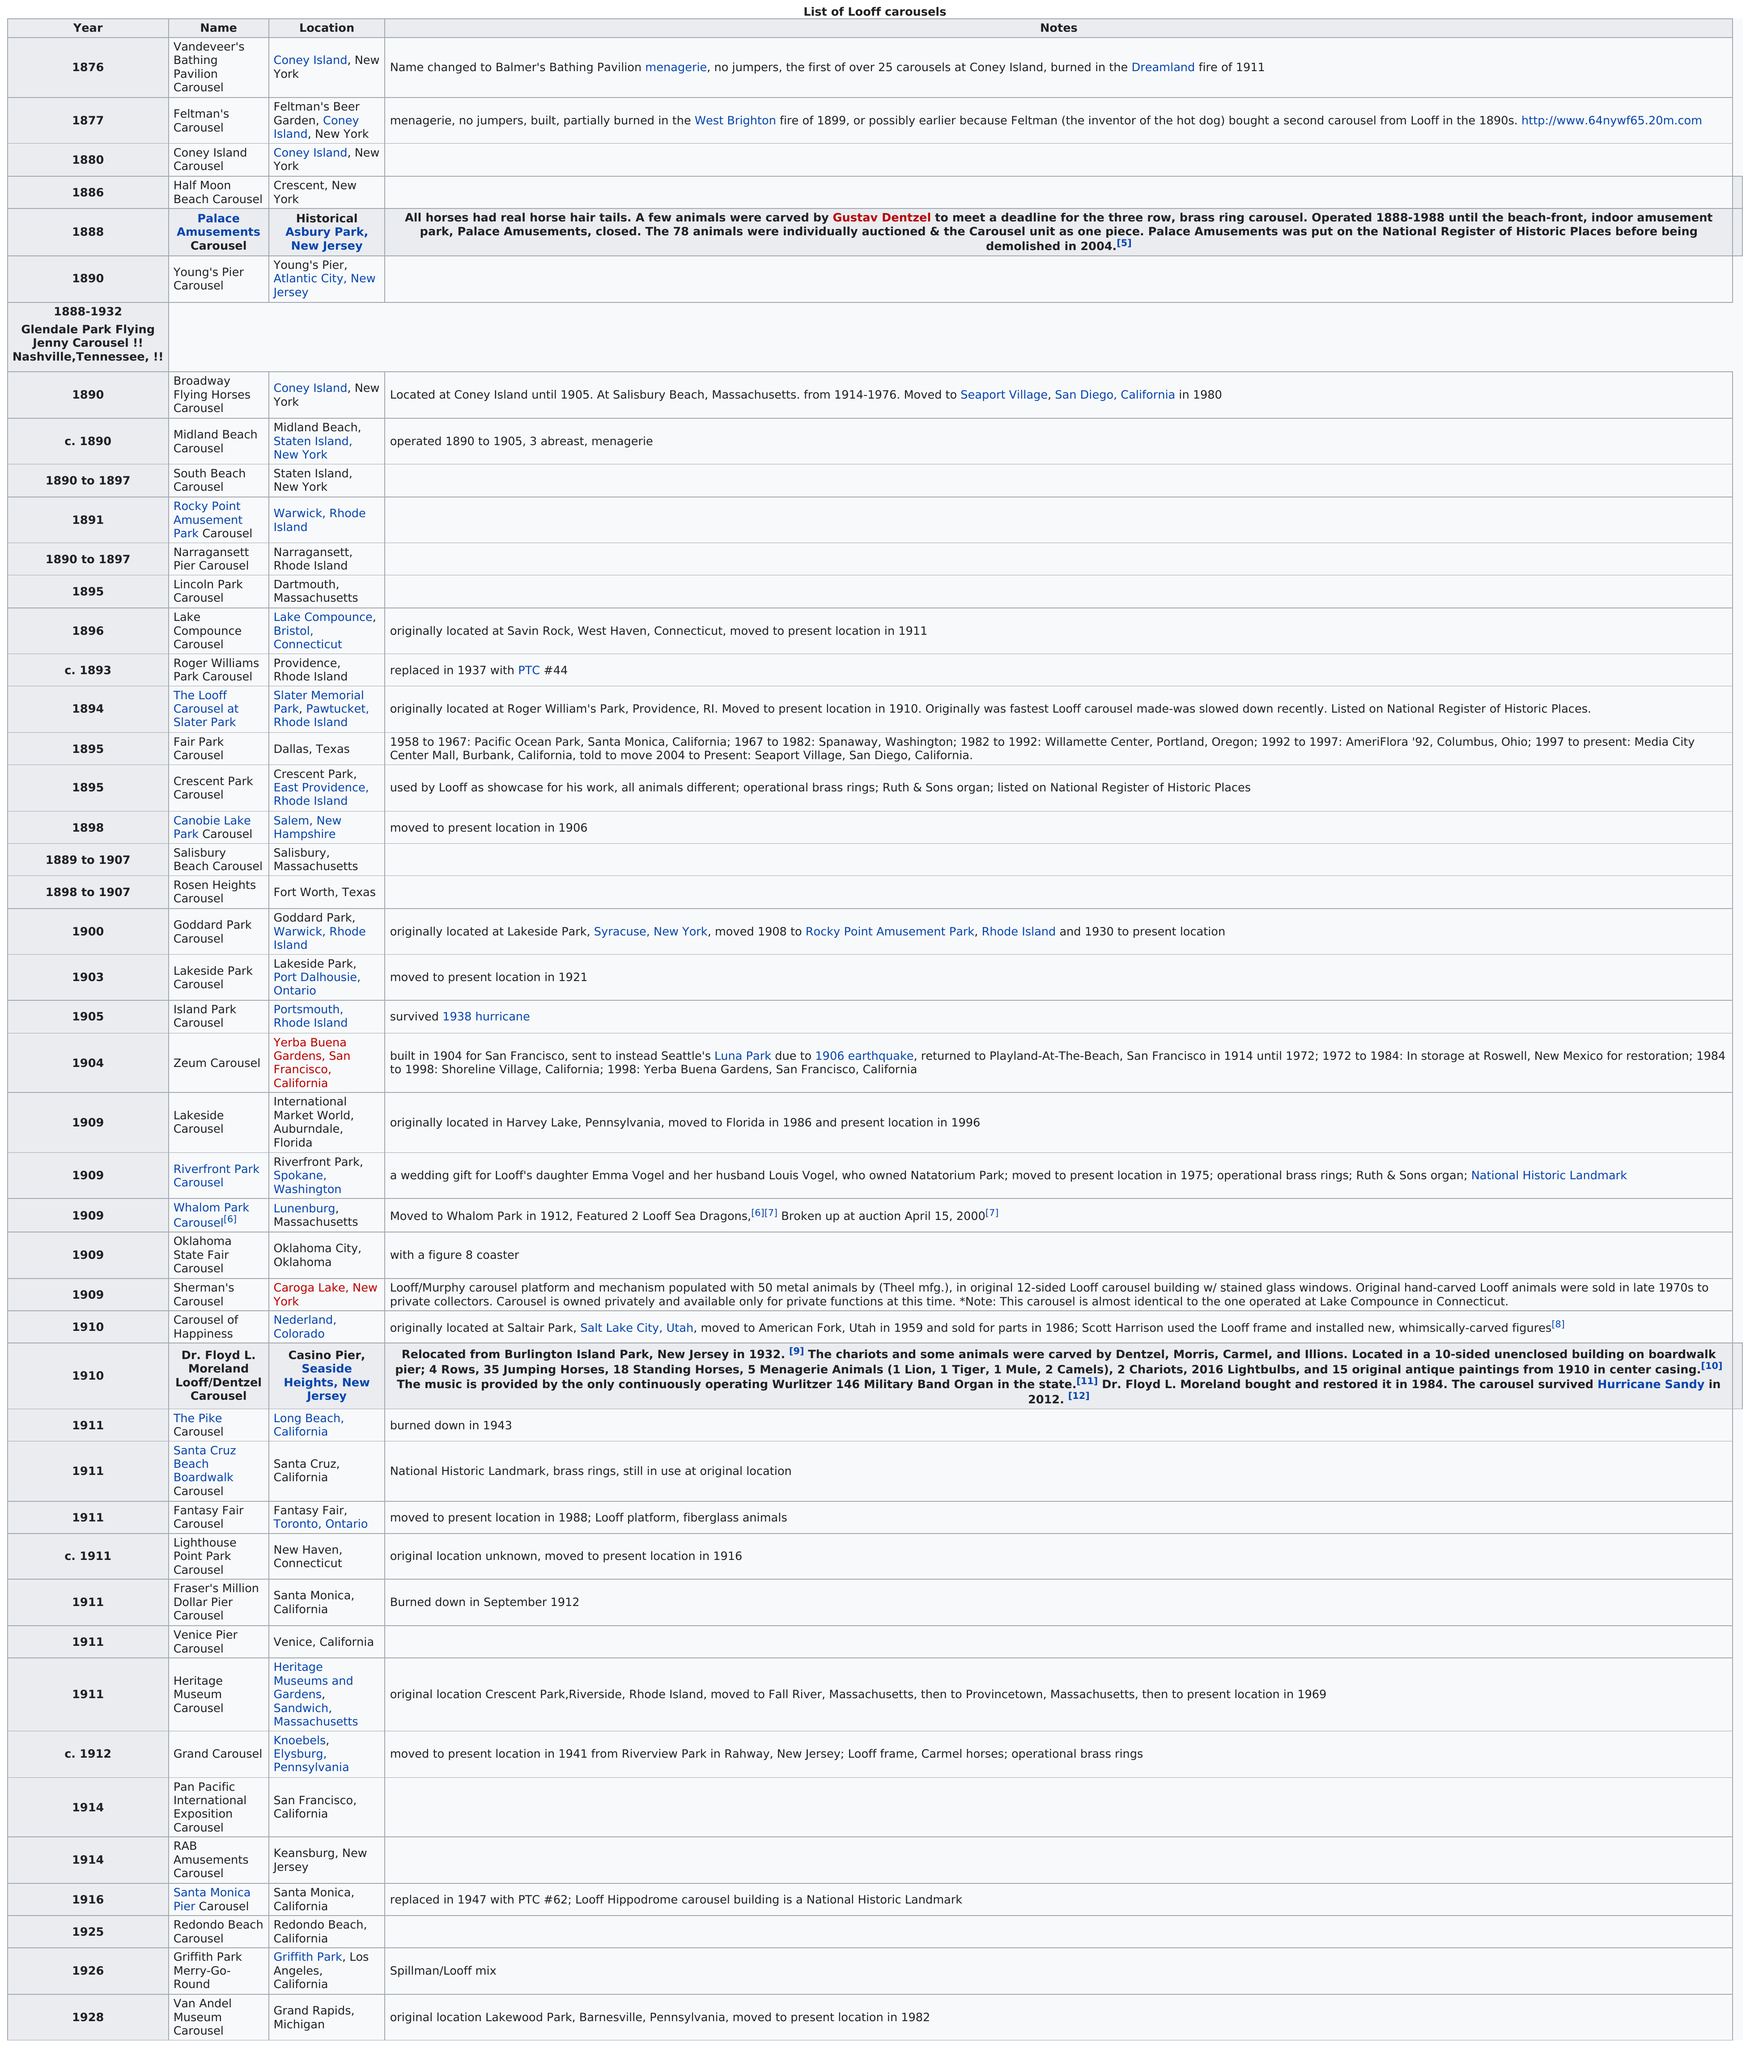Give some essential details in this illustration. The Lake Compounce Carousel was moved to its present home in 1911. The original building that housed Sherman's Carousel had 12 sides. California is the state that currently or historically housed the largest number of Looff carousels. 